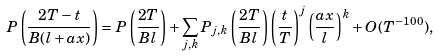Convert formula to latex. <formula><loc_0><loc_0><loc_500><loc_500>P \left ( \frac { 2 T - t } { B ( l + a x ) } \right ) = P \left ( \frac { 2 T } { B l } \right ) + \sum _ { j , k } P _ { j , k } \left ( \frac { 2 T } { B l } \right ) \left ( \frac { t } { T } \right ) ^ { j } \left ( \frac { a x } { l } \right ) ^ { k } + O ( T ^ { - 1 0 0 } ) ,</formula> 